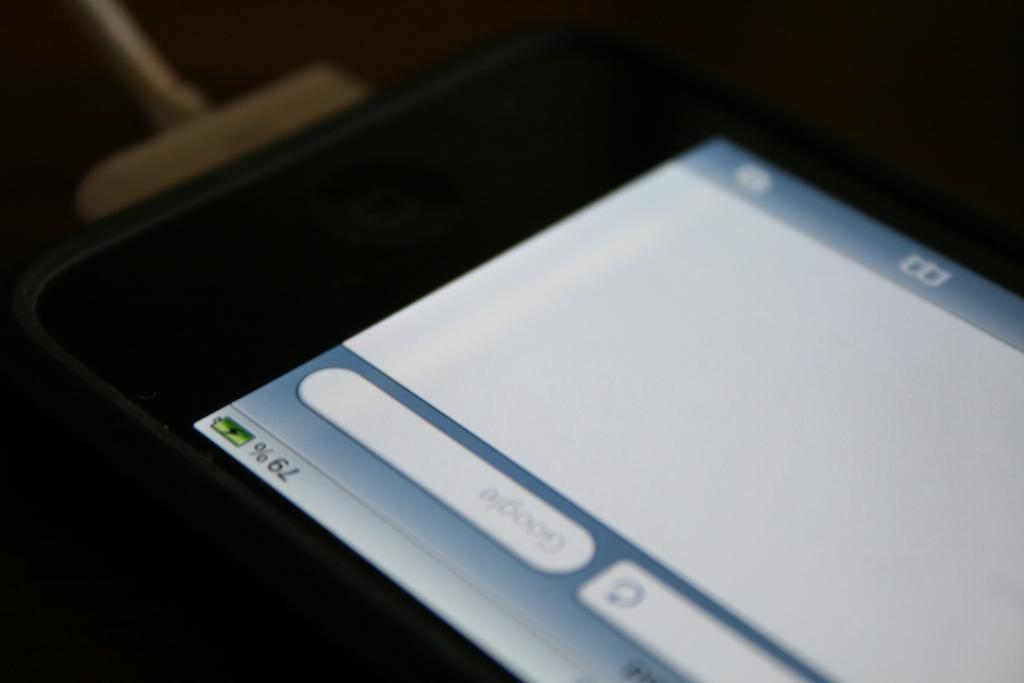<image>
Create a compact narrative representing the image presented. the cell phone is turned on and has 79% battery left 